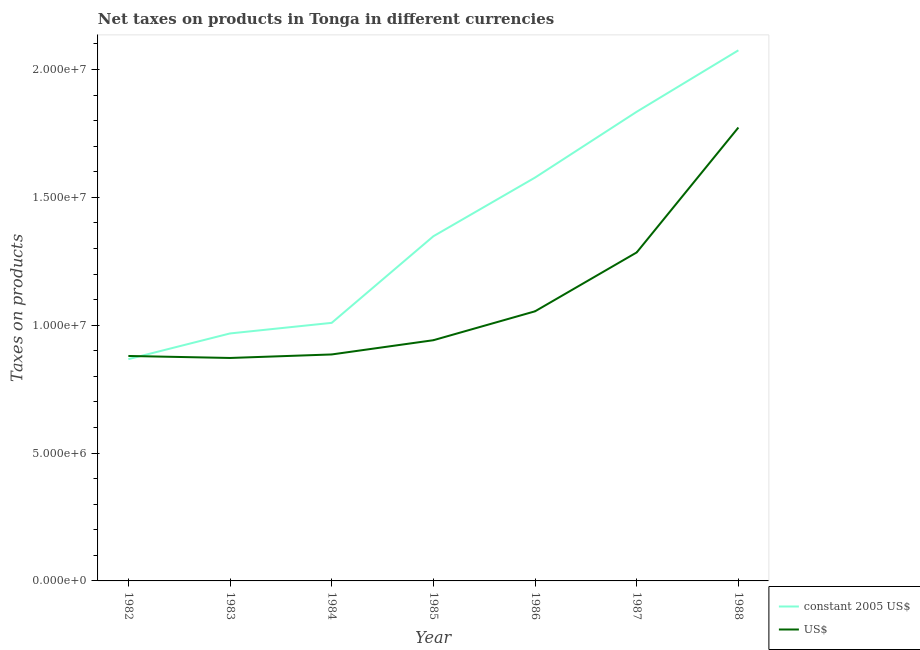Is the number of lines equal to the number of legend labels?
Your response must be concise. Yes. What is the net taxes in us$ in 1985?
Ensure brevity in your answer.  9.41e+06. Across all years, what is the maximum net taxes in us$?
Offer a terse response. 1.77e+07. Across all years, what is the minimum net taxes in us$?
Provide a short and direct response. 8.72e+06. In which year was the net taxes in us$ maximum?
Give a very brief answer. 1988. What is the total net taxes in constant 2005 us$ in the graph?
Offer a terse response. 9.68e+07. What is the difference between the net taxes in us$ in 1982 and that in 1983?
Offer a terse response. 7.82e+04. What is the difference between the net taxes in us$ in 1986 and the net taxes in constant 2005 us$ in 1988?
Offer a terse response. -1.02e+07. What is the average net taxes in us$ per year?
Your answer should be very brief. 1.10e+07. In the year 1986, what is the difference between the net taxes in us$ and net taxes in constant 2005 us$?
Your response must be concise. -5.23e+06. In how many years, is the net taxes in us$ greater than 8000000 units?
Provide a short and direct response. 7. What is the ratio of the net taxes in us$ in 1984 to that in 1985?
Your answer should be very brief. 0.94. Is the difference between the net taxes in us$ in 1983 and 1987 greater than the difference between the net taxes in constant 2005 us$ in 1983 and 1987?
Ensure brevity in your answer.  Yes. What is the difference between the highest and the second highest net taxes in us$?
Provide a short and direct response. 4.88e+06. What is the difference between the highest and the lowest net taxes in us$?
Your answer should be compact. 9.01e+06. In how many years, is the net taxes in us$ greater than the average net taxes in us$ taken over all years?
Provide a short and direct response. 2. Does the net taxes in constant 2005 us$ monotonically increase over the years?
Give a very brief answer. Yes. Is the net taxes in us$ strictly less than the net taxes in constant 2005 us$ over the years?
Keep it short and to the point. No. How many lines are there?
Provide a short and direct response. 2. How many years are there in the graph?
Offer a terse response. 7. Are the values on the major ticks of Y-axis written in scientific E-notation?
Make the answer very short. Yes. Does the graph contain grids?
Provide a short and direct response. No. What is the title of the graph?
Ensure brevity in your answer.  Net taxes on products in Tonga in different currencies. What is the label or title of the X-axis?
Ensure brevity in your answer.  Year. What is the label or title of the Y-axis?
Give a very brief answer. Taxes on products. What is the Taxes on products in constant 2005 US$ in 1982?
Give a very brief answer. 8.67e+06. What is the Taxes on products of US$ in 1982?
Give a very brief answer. 8.80e+06. What is the Taxes on products in constant 2005 US$ in 1983?
Keep it short and to the point. 9.68e+06. What is the Taxes on products in US$ in 1983?
Keep it short and to the point. 8.72e+06. What is the Taxes on products in constant 2005 US$ in 1984?
Your answer should be very brief. 1.01e+07. What is the Taxes on products of US$ in 1984?
Your answer should be very brief. 8.86e+06. What is the Taxes on products in constant 2005 US$ in 1985?
Your answer should be very brief. 1.35e+07. What is the Taxes on products in US$ in 1985?
Your answer should be very brief. 9.41e+06. What is the Taxes on products of constant 2005 US$ in 1986?
Your response must be concise. 1.58e+07. What is the Taxes on products of US$ in 1986?
Your answer should be very brief. 1.05e+07. What is the Taxes on products in constant 2005 US$ in 1987?
Offer a very short reply. 1.83e+07. What is the Taxes on products in US$ in 1987?
Offer a very short reply. 1.28e+07. What is the Taxes on products of constant 2005 US$ in 1988?
Offer a very short reply. 2.08e+07. What is the Taxes on products in US$ in 1988?
Your answer should be compact. 1.77e+07. Across all years, what is the maximum Taxes on products of constant 2005 US$?
Offer a terse response. 2.08e+07. Across all years, what is the maximum Taxes on products of US$?
Offer a terse response. 1.77e+07. Across all years, what is the minimum Taxes on products of constant 2005 US$?
Your answer should be very brief. 8.67e+06. Across all years, what is the minimum Taxes on products in US$?
Offer a very short reply. 8.72e+06. What is the total Taxes on products of constant 2005 US$ in the graph?
Provide a short and direct response. 9.68e+07. What is the total Taxes on products in US$ in the graph?
Keep it short and to the point. 7.69e+07. What is the difference between the Taxes on products in constant 2005 US$ in 1982 and that in 1983?
Your response must be concise. -1.00e+06. What is the difference between the Taxes on products in US$ in 1982 and that in 1983?
Your response must be concise. 7.82e+04. What is the difference between the Taxes on products in constant 2005 US$ in 1982 and that in 1984?
Provide a succinct answer. -1.42e+06. What is the difference between the Taxes on products in US$ in 1982 and that in 1984?
Provide a succinct answer. -5.93e+04. What is the difference between the Taxes on products of constant 2005 US$ in 1982 and that in 1985?
Keep it short and to the point. -4.81e+06. What is the difference between the Taxes on products in US$ in 1982 and that in 1985?
Your answer should be compact. -6.16e+05. What is the difference between the Taxes on products of constant 2005 US$ in 1982 and that in 1986?
Ensure brevity in your answer.  -7.10e+06. What is the difference between the Taxes on products in US$ in 1982 and that in 1986?
Provide a short and direct response. -1.75e+06. What is the difference between the Taxes on products of constant 2005 US$ in 1982 and that in 1987?
Ensure brevity in your answer.  -9.68e+06. What is the difference between the Taxes on products in US$ in 1982 and that in 1987?
Ensure brevity in your answer.  -4.05e+06. What is the difference between the Taxes on products in constant 2005 US$ in 1982 and that in 1988?
Make the answer very short. -1.21e+07. What is the difference between the Taxes on products in US$ in 1982 and that in 1988?
Offer a terse response. -8.93e+06. What is the difference between the Taxes on products of constant 2005 US$ in 1983 and that in 1984?
Provide a short and direct response. -4.14e+05. What is the difference between the Taxes on products of US$ in 1983 and that in 1984?
Give a very brief answer. -1.38e+05. What is the difference between the Taxes on products of constant 2005 US$ in 1983 and that in 1985?
Your response must be concise. -3.80e+06. What is the difference between the Taxes on products in US$ in 1983 and that in 1985?
Give a very brief answer. -6.94e+05. What is the difference between the Taxes on products of constant 2005 US$ in 1983 and that in 1986?
Your answer should be compact. -6.10e+06. What is the difference between the Taxes on products in US$ in 1983 and that in 1986?
Make the answer very short. -1.82e+06. What is the difference between the Taxes on products in constant 2005 US$ in 1983 and that in 1987?
Offer a very short reply. -8.67e+06. What is the difference between the Taxes on products of US$ in 1983 and that in 1987?
Your answer should be very brief. -4.13e+06. What is the difference between the Taxes on products of constant 2005 US$ in 1983 and that in 1988?
Provide a succinct answer. -1.11e+07. What is the difference between the Taxes on products in US$ in 1983 and that in 1988?
Your answer should be compact. -9.01e+06. What is the difference between the Taxes on products of constant 2005 US$ in 1984 and that in 1985?
Offer a very short reply. -3.39e+06. What is the difference between the Taxes on products in US$ in 1984 and that in 1985?
Your answer should be very brief. -5.57e+05. What is the difference between the Taxes on products in constant 2005 US$ in 1984 and that in 1986?
Keep it short and to the point. -5.68e+06. What is the difference between the Taxes on products of US$ in 1984 and that in 1986?
Ensure brevity in your answer.  -1.69e+06. What is the difference between the Taxes on products of constant 2005 US$ in 1984 and that in 1987?
Provide a succinct answer. -8.26e+06. What is the difference between the Taxes on products of US$ in 1984 and that in 1987?
Offer a terse response. -3.99e+06. What is the difference between the Taxes on products in constant 2005 US$ in 1984 and that in 1988?
Keep it short and to the point. -1.07e+07. What is the difference between the Taxes on products in US$ in 1984 and that in 1988?
Offer a very short reply. -8.87e+06. What is the difference between the Taxes on products in constant 2005 US$ in 1985 and that in 1986?
Your answer should be very brief. -2.30e+06. What is the difference between the Taxes on products in US$ in 1985 and that in 1986?
Keep it short and to the point. -1.13e+06. What is the difference between the Taxes on products in constant 2005 US$ in 1985 and that in 1987?
Your response must be concise. -4.87e+06. What is the difference between the Taxes on products of US$ in 1985 and that in 1987?
Offer a terse response. -3.43e+06. What is the difference between the Taxes on products in constant 2005 US$ in 1985 and that in 1988?
Your answer should be compact. -7.27e+06. What is the difference between the Taxes on products of US$ in 1985 and that in 1988?
Give a very brief answer. -8.32e+06. What is the difference between the Taxes on products of constant 2005 US$ in 1986 and that in 1987?
Your answer should be compact. -2.57e+06. What is the difference between the Taxes on products of US$ in 1986 and that in 1987?
Offer a terse response. -2.30e+06. What is the difference between the Taxes on products in constant 2005 US$ in 1986 and that in 1988?
Ensure brevity in your answer.  -4.98e+06. What is the difference between the Taxes on products in US$ in 1986 and that in 1988?
Provide a succinct answer. -7.19e+06. What is the difference between the Taxes on products in constant 2005 US$ in 1987 and that in 1988?
Your answer should be very brief. -2.40e+06. What is the difference between the Taxes on products of US$ in 1987 and that in 1988?
Your answer should be compact. -4.88e+06. What is the difference between the Taxes on products in constant 2005 US$ in 1982 and the Taxes on products in US$ in 1983?
Provide a short and direct response. -4.58e+04. What is the difference between the Taxes on products in constant 2005 US$ in 1982 and the Taxes on products in US$ in 1984?
Ensure brevity in your answer.  -1.83e+05. What is the difference between the Taxes on products of constant 2005 US$ in 1982 and the Taxes on products of US$ in 1985?
Give a very brief answer. -7.40e+05. What is the difference between the Taxes on products in constant 2005 US$ in 1982 and the Taxes on products in US$ in 1986?
Make the answer very short. -1.87e+06. What is the difference between the Taxes on products in constant 2005 US$ in 1982 and the Taxes on products in US$ in 1987?
Your answer should be very brief. -4.17e+06. What is the difference between the Taxes on products in constant 2005 US$ in 1982 and the Taxes on products in US$ in 1988?
Your answer should be compact. -9.06e+06. What is the difference between the Taxes on products in constant 2005 US$ in 1983 and the Taxes on products in US$ in 1984?
Give a very brief answer. 8.22e+05. What is the difference between the Taxes on products in constant 2005 US$ in 1983 and the Taxes on products in US$ in 1985?
Offer a very short reply. 2.65e+05. What is the difference between the Taxes on products of constant 2005 US$ in 1983 and the Taxes on products of US$ in 1986?
Your answer should be very brief. -8.66e+05. What is the difference between the Taxes on products in constant 2005 US$ in 1983 and the Taxes on products in US$ in 1987?
Ensure brevity in your answer.  -3.17e+06. What is the difference between the Taxes on products of constant 2005 US$ in 1983 and the Taxes on products of US$ in 1988?
Offer a terse response. -8.05e+06. What is the difference between the Taxes on products of constant 2005 US$ in 1984 and the Taxes on products of US$ in 1985?
Your response must be concise. 6.79e+05. What is the difference between the Taxes on products in constant 2005 US$ in 1984 and the Taxes on products in US$ in 1986?
Your response must be concise. -4.52e+05. What is the difference between the Taxes on products of constant 2005 US$ in 1984 and the Taxes on products of US$ in 1987?
Your answer should be compact. -2.75e+06. What is the difference between the Taxes on products in constant 2005 US$ in 1984 and the Taxes on products in US$ in 1988?
Offer a very short reply. -7.64e+06. What is the difference between the Taxes on products in constant 2005 US$ in 1985 and the Taxes on products in US$ in 1986?
Offer a very short reply. 2.94e+06. What is the difference between the Taxes on products of constant 2005 US$ in 1985 and the Taxes on products of US$ in 1987?
Give a very brief answer. 6.32e+05. What is the difference between the Taxes on products in constant 2005 US$ in 1985 and the Taxes on products in US$ in 1988?
Provide a succinct answer. -4.25e+06. What is the difference between the Taxes on products in constant 2005 US$ in 1986 and the Taxes on products in US$ in 1987?
Your answer should be compact. 2.93e+06. What is the difference between the Taxes on products of constant 2005 US$ in 1986 and the Taxes on products of US$ in 1988?
Offer a very short reply. -1.96e+06. What is the difference between the Taxes on products of constant 2005 US$ in 1987 and the Taxes on products of US$ in 1988?
Your response must be concise. 6.17e+05. What is the average Taxes on products in constant 2005 US$ per year?
Give a very brief answer. 1.38e+07. What is the average Taxes on products of US$ per year?
Your answer should be very brief. 1.10e+07. In the year 1982, what is the difference between the Taxes on products in constant 2005 US$ and Taxes on products in US$?
Keep it short and to the point. -1.24e+05. In the year 1983, what is the difference between the Taxes on products in constant 2005 US$ and Taxes on products in US$?
Keep it short and to the point. 9.59e+05. In the year 1984, what is the difference between the Taxes on products of constant 2005 US$ and Taxes on products of US$?
Ensure brevity in your answer.  1.24e+06. In the year 1985, what is the difference between the Taxes on products of constant 2005 US$ and Taxes on products of US$?
Give a very brief answer. 4.07e+06. In the year 1986, what is the difference between the Taxes on products of constant 2005 US$ and Taxes on products of US$?
Keep it short and to the point. 5.23e+06. In the year 1987, what is the difference between the Taxes on products in constant 2005 US$ and Taxes on products in US$?
Provide a succinct answer. 5.50e+06. In the year 1988, what is the difference between the Taxes on products in constant 2005 US$ and Taxes on products in US$?
Provide a short and direct response. 3.02e+06. What is the ratio of the Taxes on products of constant 2005 US$ in 1982 to that in 1983?
Make the answer very short. 0.9. What is the ratio of the Taxes on products of constant 2005 US$ in 1982 to that in 1984?
Make the answer very short. 0.86. What is the ratio of the Taxes on products in US$ in 1982 to that in 1984?
Make the answer very short. 0.99. What is the ratio of the Taxes on products in constant 2005 US$ in 1982 to that in 1985?
Ensure brevity in your answer.  0.64. What is the ratio of the Taxes on products of US$ in 1982 to that in 1985?
Your answer should be compact. 0.93. What is the ratio of the Taxes on products of constant 2005 US$ in 1982 to that in 1986?
Keep it short and to the point. 0.55. What is the ratio of the Taxes on products of US$ in 1982 to that in 1986?
Provide a succinct answer. 0.83. What is the ratio of the Taxes on products of constant 2005 US$ in 1982 to that in 1987?
Provide a short and direct response. 0.47. What is the ratio of the Taxes on products in US$ in 1982 to that in 1987?
Offer a terse response. 0.68. What is the ratio of the Taxes on products of constant 2005 US$ in 1982 to that in 1988?
Your response must be concise. 0.42. What is the ratio of the Taxes on products of US$ in 1982 to that in 1988?
Your answer should be very brief. 0.5. What is the ratio of the Taxes on products of constant 2005 US$ in 1983 to that in 1984?
Offer a terse response. 0.96. What is the ratio of the Taxes on products of US$ in 1983 to that in 1984?
Make the answer very short. 0.98. What is the ratio of the Taxes on products of constant 2005 US$ in 1983 to that in 1985?
Your answer should be compact. 0.72. What is the ratio of the Taxes on products in US$ in 1983 to that in 1985?
Your response must be concise. 0.93. What is the ratio of the Taxes on products in constant 2005 US$ in 1983 to that in 1986?
Your response must be concise. 0.61. What is the ratio of the Taxes on products of US$ in 1983 to that in 1986?
Offer a terse response. 0.83. What is the ratio of the Taxes on products in constant 2005 US$ in 1983 to that in 1987?
Your answer should be compact. 0.53. What is the ratio of the Taxes on products in US$ in 1983 to that in 1987?
Offer a terse response. 0.68. What is the ratio of the Taxes on products of constant 2005 US$ in 1983 to that in 1988?
Offer a terse response. 0.47. What is the ratio of the Taxes on products in US$ in 1983 to that in 1988?
Offer a very short reply. 0.49. What is the ratio of the Taxes on products of constant 2005 US$ in 1984 to that in 1985?
Ensure brevity in your answer.  0.75. What is the ratio of the Taxes on products in US$ in 1984 to that in 1985?
Offer a terse response. 0.94. What is the ratio of the Taxes on products in constant 2005 US$ in 1984 to that in 1986?
Give a very brief answer. 0.64. What is the ratio of the Taxes on products in US$ in 1984 to that in 1986?
Your answer should be very brief. 0.84. What is the ratio of the Taxes on products of constant 2005 US$ in 1984 to that in 1987?
Keep it short and to the point. 0.55. What is the ratio of the Taxes on products of US$ in 1984 to that in 1987?
Ensure brevity in your answer.  0.69. What is the ratio of the Taxes on products in constant 2005 US$ in 1984 to that in 1988?
Provide a succinct answer. 0.49. What is the ratio of the Taxes on products of US$ in 1984 to that in 1988?
Provide a short and direct response. 0.5. What is the ratio of the Taxes on products in constant 2005 US$ in 1985 to that in 1986?
Your answer should be very brief. 0.85. What is the ratio of the Taxes on products in US$ in 1985 to that in 1986?
Give a very brief answer. 0.89. What is the ratio of the Taxes on products of constant 2005 US$ in 1985 to that in 1987?
Your answer should be very brief. 0.73. What is the ratio of the Taxes on products of US$ in 1985 to that in 1987?
Your answer should be compact. 0.73. What is the ratio of the Taxes on products of constant 2005 US$ in 1985 to that in 1988?
Your answer should be very brief. 0.65. What is the ratio of the Taxes on products in US$ in 1985 to that in 1988?
Ensure brevity in your answer.  0.53. What is the ratio of the Taxes on products in constant 2005 US$ in 1986 to that in 1987?
Offer a very short reply. 0.86. What is the ratio of the Taxes on products in US$ in 1986 to that in 1987?
Give a very brief answer. 0.82. What is the ratio of the Taxes on products of constant 2005 US$ in 1986 to that in 1988?
Ensure brevity in your answer.  0.76. What is the ratio of the Taxes on products in US$ in 1986 to that in 1988?
Make the answer very short. 0.59. What is the ratio of the Taxes on products in constant 2005 US$ in 1987 to that in 1988?
Keep it short and to the point. 0.88. What is the ratio of the Taxes on products in US$ in 1987 to that in 1988?
Offer a very short reply. 0.72. What is the difference between the highest and the second highest Taxes on products of constant 2005 US$?
Provide a succinct answer. 2.40e+06. What is the difference between the highest and the second highest Taxes on products in US$?
Provide a short and direct response. 4.88e+06. What is the difference between the highest and the lowest Taxes on products of constant 2005 US$?
Offer a terse response. 1.21e+07. What is the difference between the highest and the lowest Taxes on products in US$?
Offer a very short reply. 9.01e+06. 